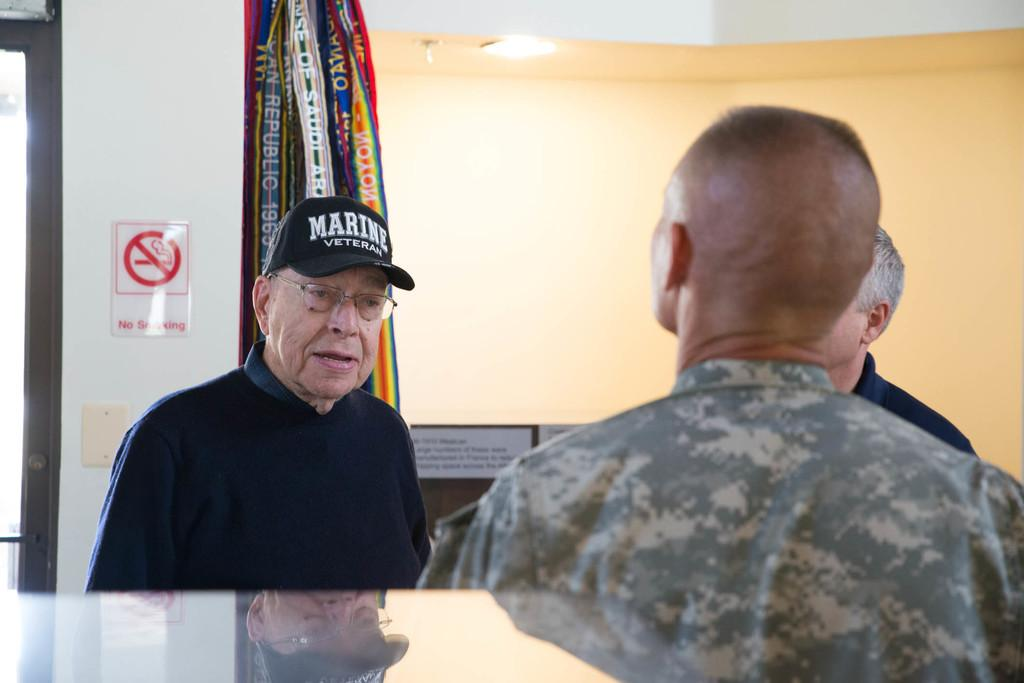Who is the man in the image looking at? The man in the image is looking at another person. What can be seen on the wall in the image? There is a signboard on the wall in the image. What decorative elements are present in the image? Colorful ribbons are present in the image. What is the source of illumination in the image? There is light in the image. Is there a reflection of any person in the image? Yes, there is a reflection of the person on a glass surface in the image. How many cats are sitting on the hood of the car in the image? There are no cats or cars present in the image. What is the answer to the riddle written on the signboard in the image? The image does not contain a riddle, so we cannot determine the answer. 